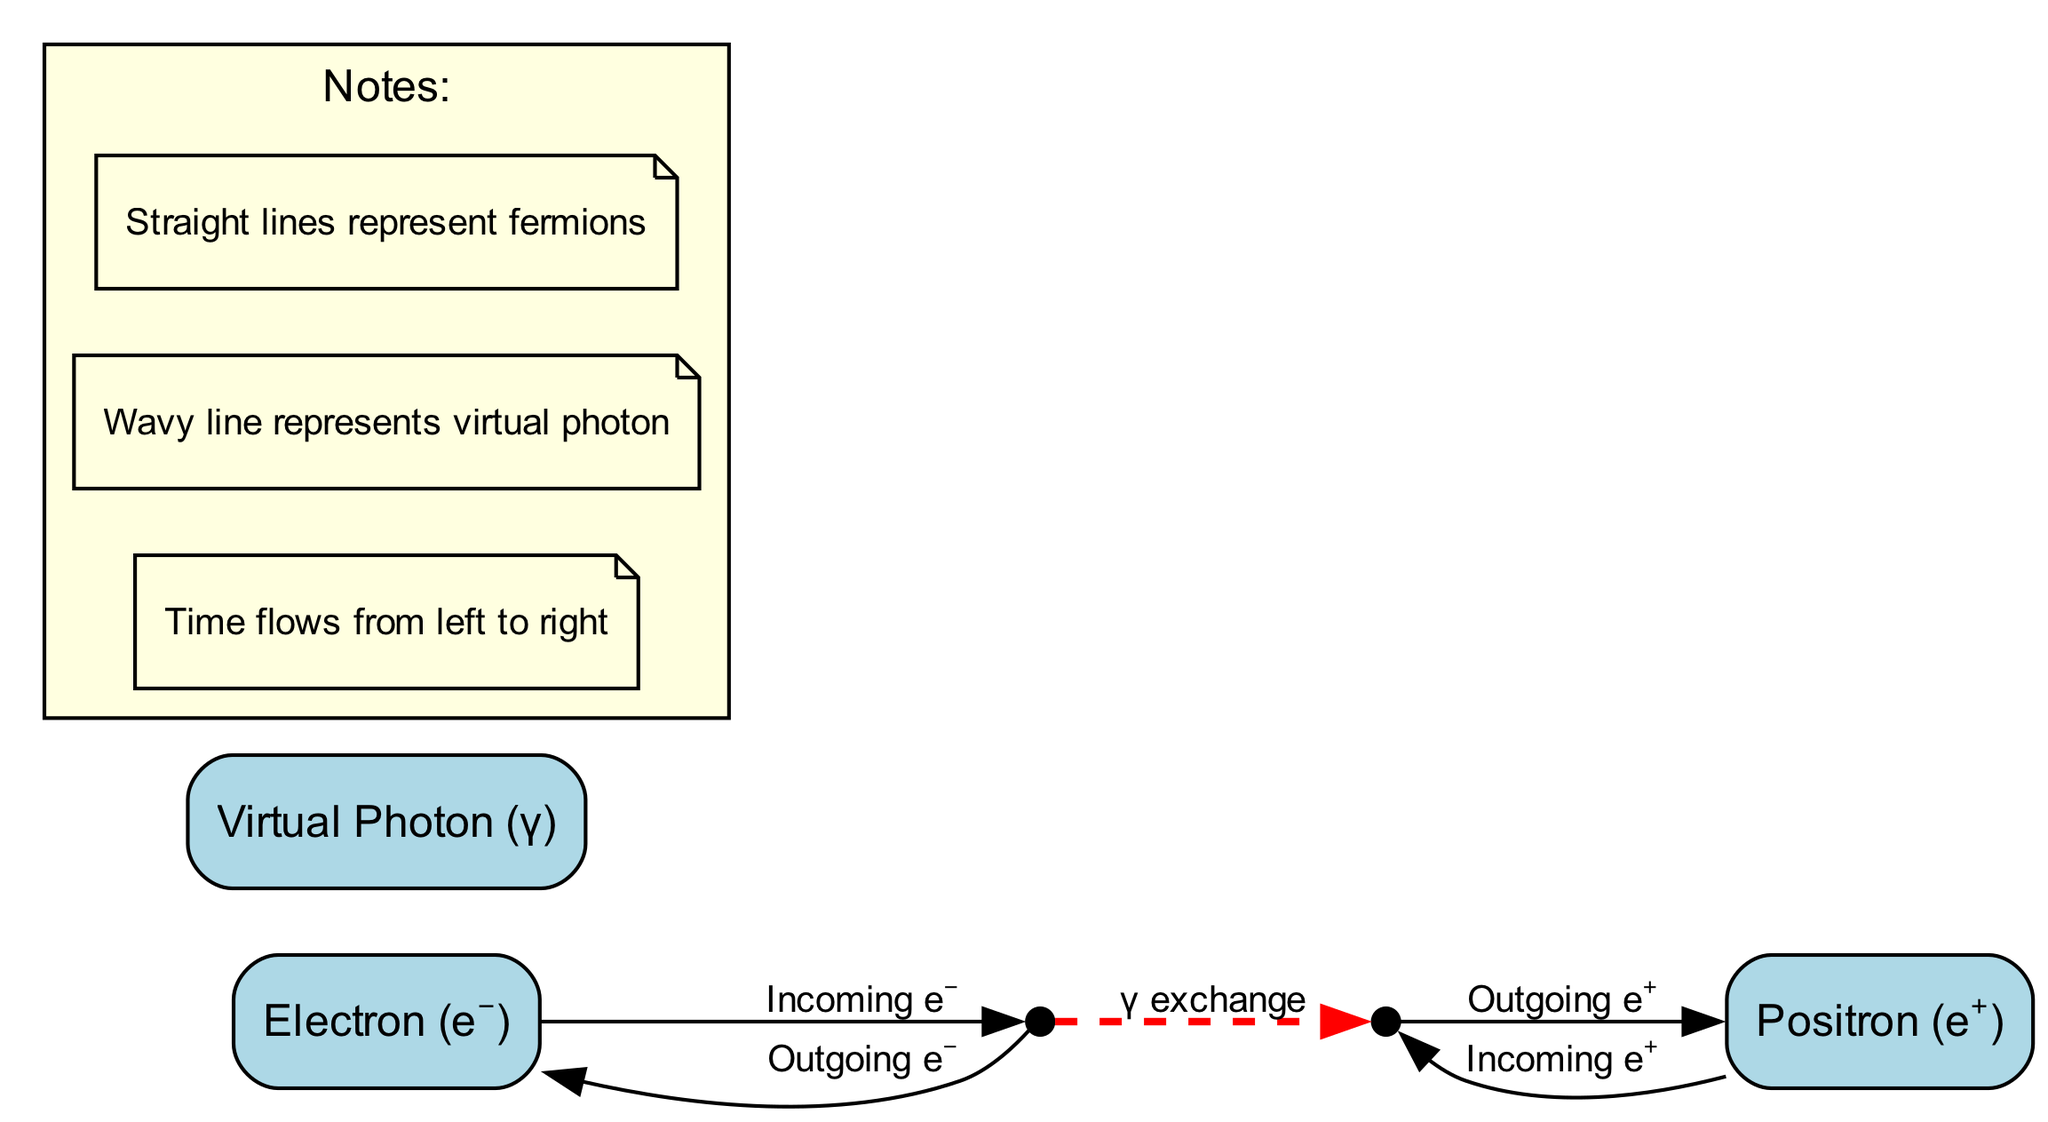What are the types of particles involved in this interaction? Observing the nodes in the diagram, the types of particles are identified as an electron (e⁻), a positron (e⁺), and a virtual photon (γ).
Answer: Electron, positron, virtual photon How many nodes are there in the diagram? The diagram contains five nodes: electron, positron, virtual photon, interaction vertex 1, and interaction vertex 2.
Answer: Five What is the direction of time in the diagram? The diagram notes indicate that time flows from left to right, meaning the interactions happen in that direction in the illustration.
Answer: Left to right What kind of line represents the exchange of the virtual photon? The wavy line in the diagram specifically represents the exchange of the virtual photon, which is indicated in the notes.
Answer: Wavy line What denotes the outgoing electron in the diagram? The outgoing electron is represented by a straight line labeled "Outgoing e⁻," which indicates the flow of the electron after the interaction.
Answer: Outgoing e⁻ What interaction occurs between the two interaction vertices? The interaction between the two vertices is labeled as "γ exchange," which depicts the exchange of the virtual photon during the particle interaction.
Answer: γ exchange How many interaction vertices are present in this Feynman diagram? There are two interaction vertices in the diagram labeled as Interaction Vertex 1 and Interaction Vertex 2.
Answer: Two Which particle is represented by the vertex on the left? The left vertex, labeled as Interaction Vertex 1, is associated with the incoming electron (e⁻) and its outgoing state as well.
Answer: Interaction Vertex 1 Which particle has the outgoing label in the context of the incoming positron? The outgoing label related to the incoming positron (e⁺) indicates its label as "Outgoing e⁺," which signifies the positron's state after the interaction.
Answer: Outgoing e⁺ 